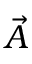<formula> <loc_0><loc_0><loc_500><loc_500>\vec { A }</formula> 